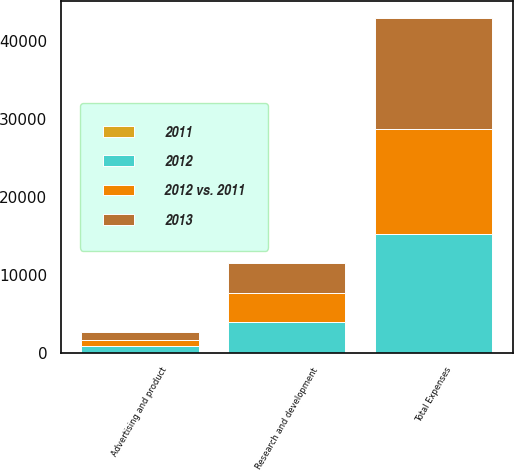<chart> <loc_0><loc_0><loc_500><loc_500><stacked_bar_chart><ecel><fcel>Advertising and product<fcel>Research and development<fcel>Total Expenses<nl><fcel>2012 vs. 2011<fcel>855<fcel>3731<fcel>13494<nl><fcel>2012<fcel>797<fcel>3904<fcel>15281<nl><fcel>2013<fcel>957<fcel>3839<fcel>14263<nl><fcel>2011<fcel>7<fcel>4<fcel>12<nl></chart> 